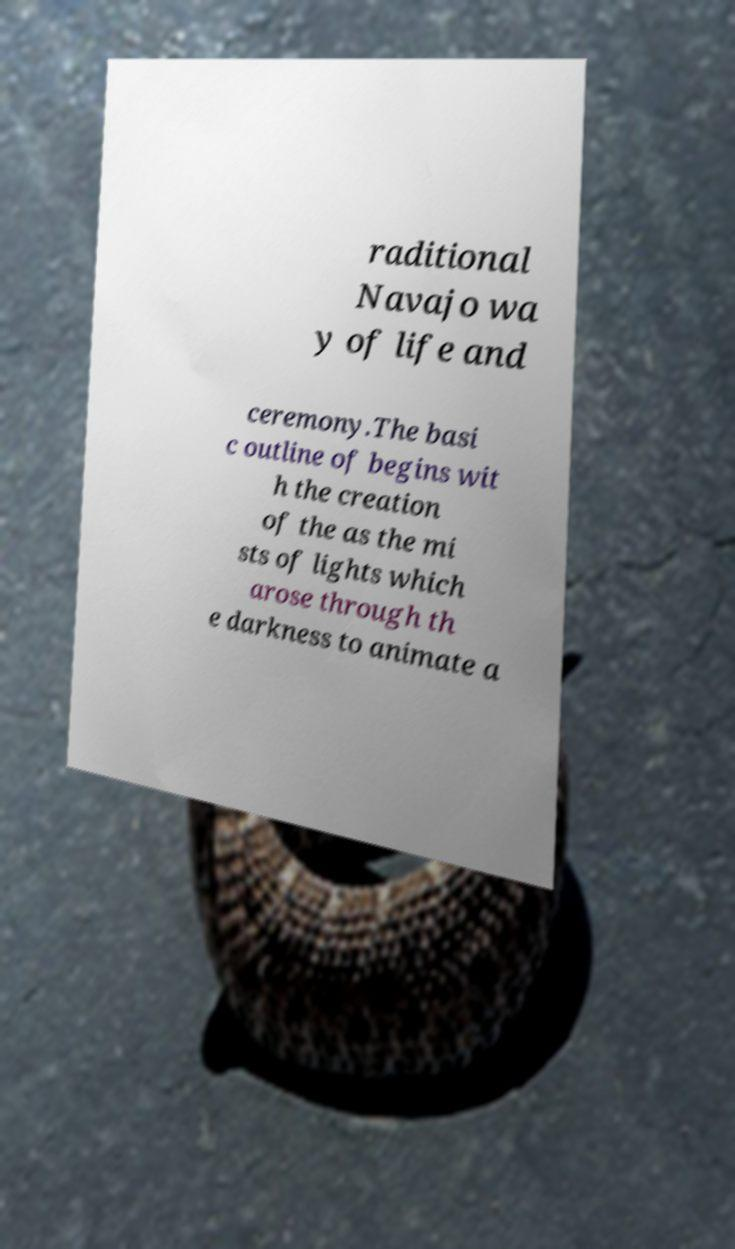What messages or text are displayed in this image? I need them in a readable, typed format. raditional Navajo wa y of life and ceremony.The basi c outline of begins wit h the creation of the as the mi sts of lights which arose through th e darkness to animate a 